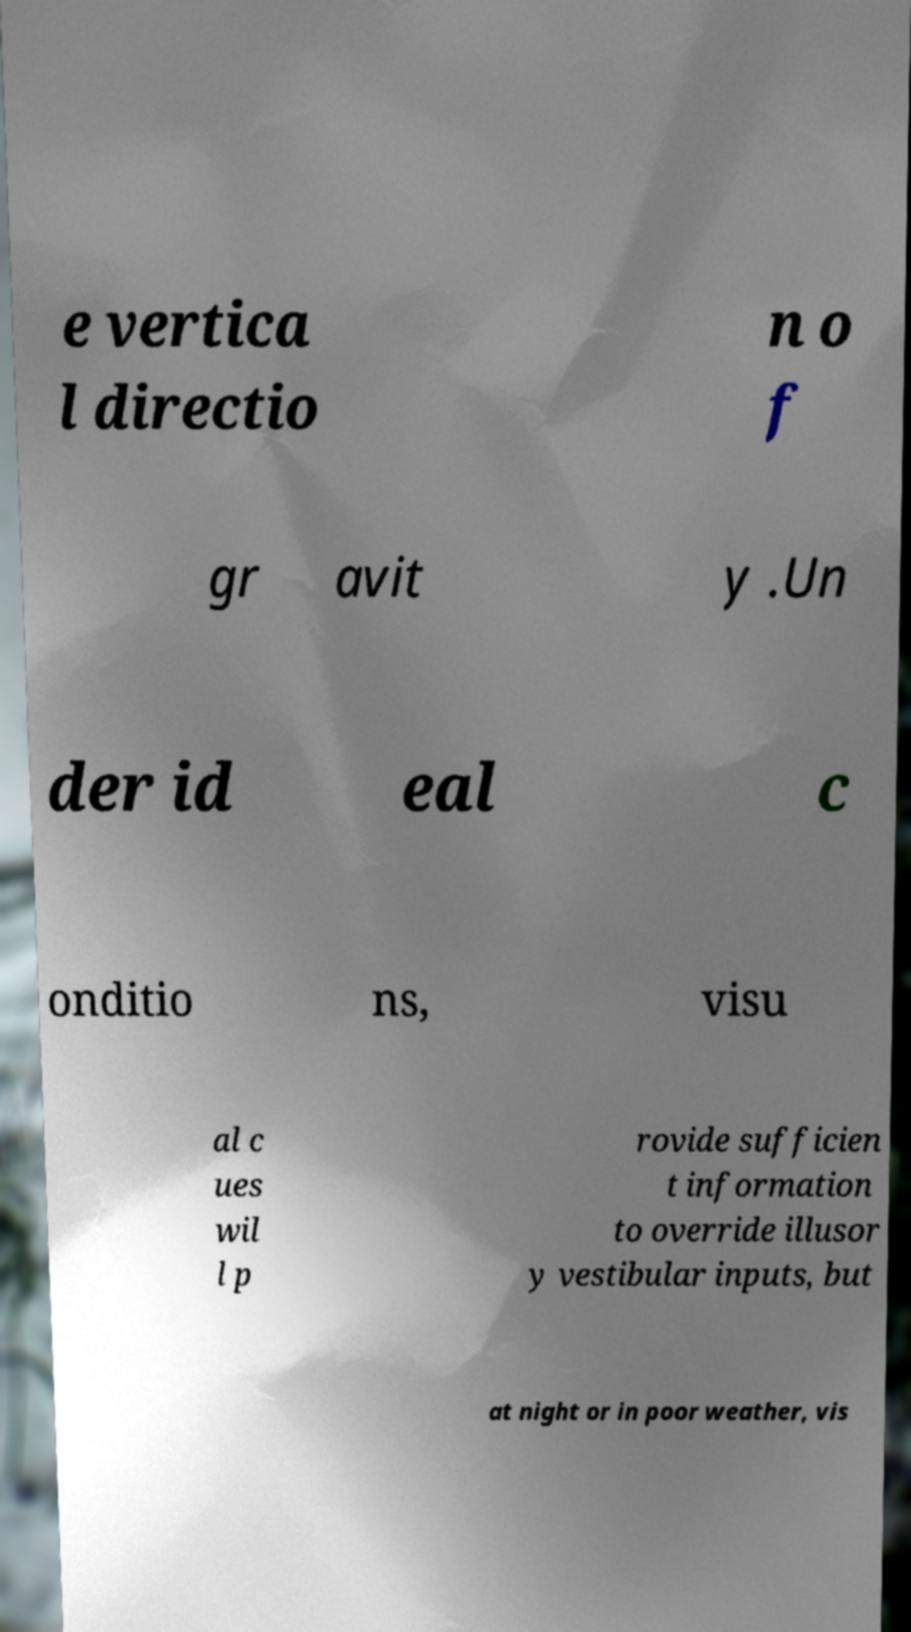Can you read and provide the text displayed in the image?This photo seems to have some interesting text. Can you extract and type it out for me? e vertica l directio n o f gr avit y .Un der id eal c onditio ns, visu al c ues wil l p rovide sufficien t information to override illusor y vestibular inputs, but at night or in poor weather, vis 